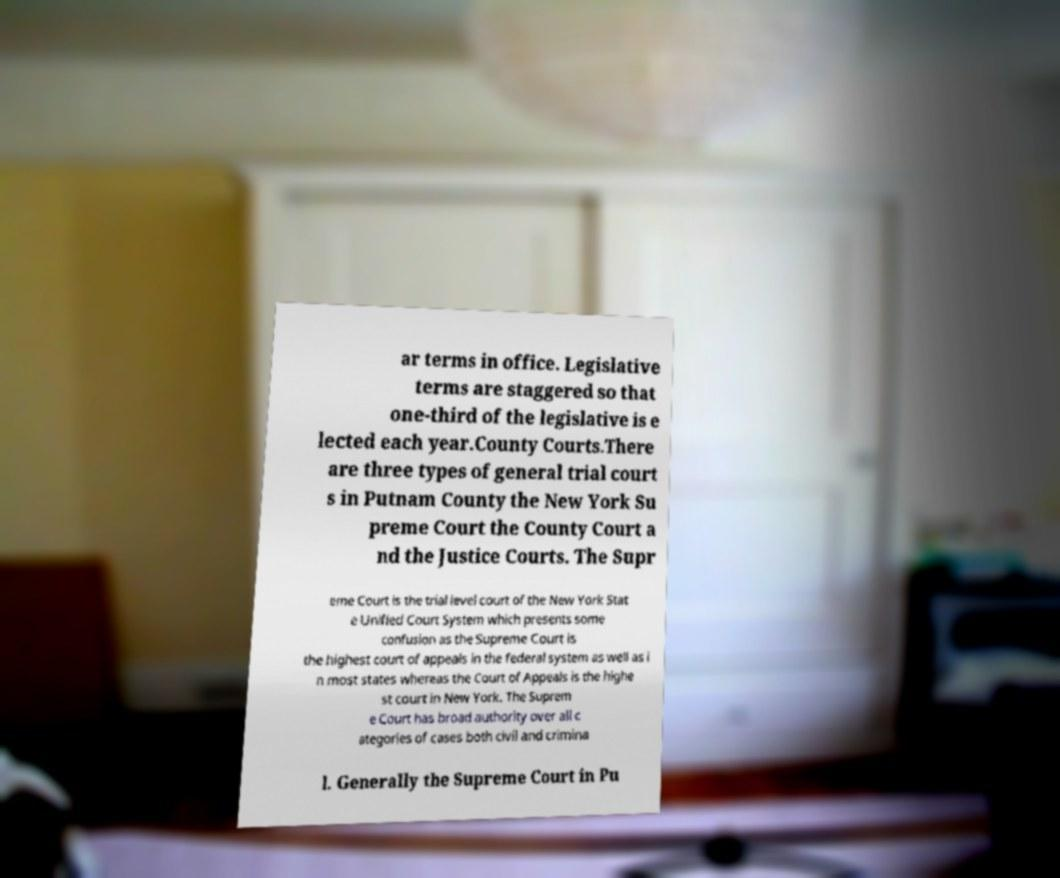Please read and relay the text visible in this image. What does it say? ar terms in office. Legislative terms are staggered so that one-third of the legislative is e lected each year.County Courts.There are three types of general trial court s in Putnam County the New York Su preme Court the County Court a nd the Justice Courts. The Supr eme Court is the trial level court of the New York Stat e Unified Court System which presents some confusion as the Supreme Court is the highest court of appeals in the federal system as well as i n most states whereas the Court of Appeals is the highe st court in New York. The Suprem e Court has broad authority over all c ategories of cases both civil and crimina l. Generally the Supreme Court in Pu 